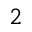<formula> <loc_0><loc_0><loc_500><loc_500>^ { 2 }</formula> 